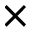Convert formula to latex. <formula><loc_0><loc_0><loc_500><loc_500>\times</formula> 